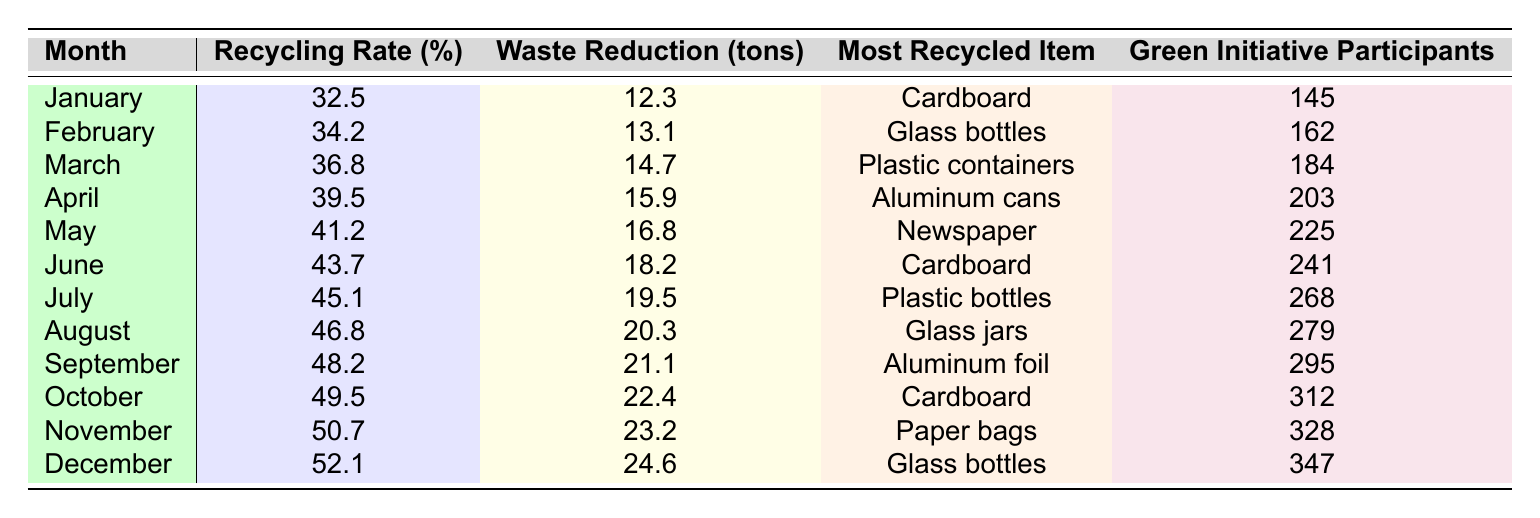What was the highest recycling rate recorded in the past year? Looking at the table, the highest recycling rate is found in December, which shows a rate of 52.1%.
Answer: 52.1% Which month had the most green initiative participants? To find the month with the most participants, we compare all the values in the "Green Initiative Participants" column, and we see that December had the highest number at 347.
Answer: December How much waste was reduced in November? In November, the waste reduction is recorded as 23.2 tons, which is stated directly in the table.
Answer: 23.2 tons What is the average recycling rate across the year? To calculate the average, sum the recycling rates for all months (32.5 + 34.2 + ... + 52.1 = 503.1), then divide by 12 (the number of months), which gives an average of approximately 41.9%.
Answer: 41.9% Did the recycling rate increase every month? Examining the recycling rates month by month from January to December, we see that each month shows a higher rate than the previous one, confirming that the rate increased consistently.
Answer: Yes In which month was plastic containers the most recycled item? The table clearly states that plastic containers were the most recycled item in March, as indicated under that month's entry.
Answer: March What was the difference in waste reduction between January and August? The waste reduction for January was 12.3 tons and for August was 20.3 tons. The difference is 20.3 - 12.3 = 8 tons.
Answer: 8 tons Which item was recycled the least in terms of tonnage in March? The table indicates that in March, plastic containers were the most recycled item, indicating it had the highest tonnage. To find the least, check other months, and since only one item is listed per month, the structure suggests it is only a matter of lowest among the months.
Answer: Unknown (as each month has one entry) How many participants joined the green initiative in June compared to April? In June, there were 241 participants, and in April, there were 203 participants. The difference is 241 - 203 = 38 more participants in June.
Answer: 38 more participants in June Which month showed the least amount of waste reduction throughout the year? By reviewing the waste reduction data month-by-month, January shows the least waste reduction at 12.3 tons as shown in the table.
Answer: January 